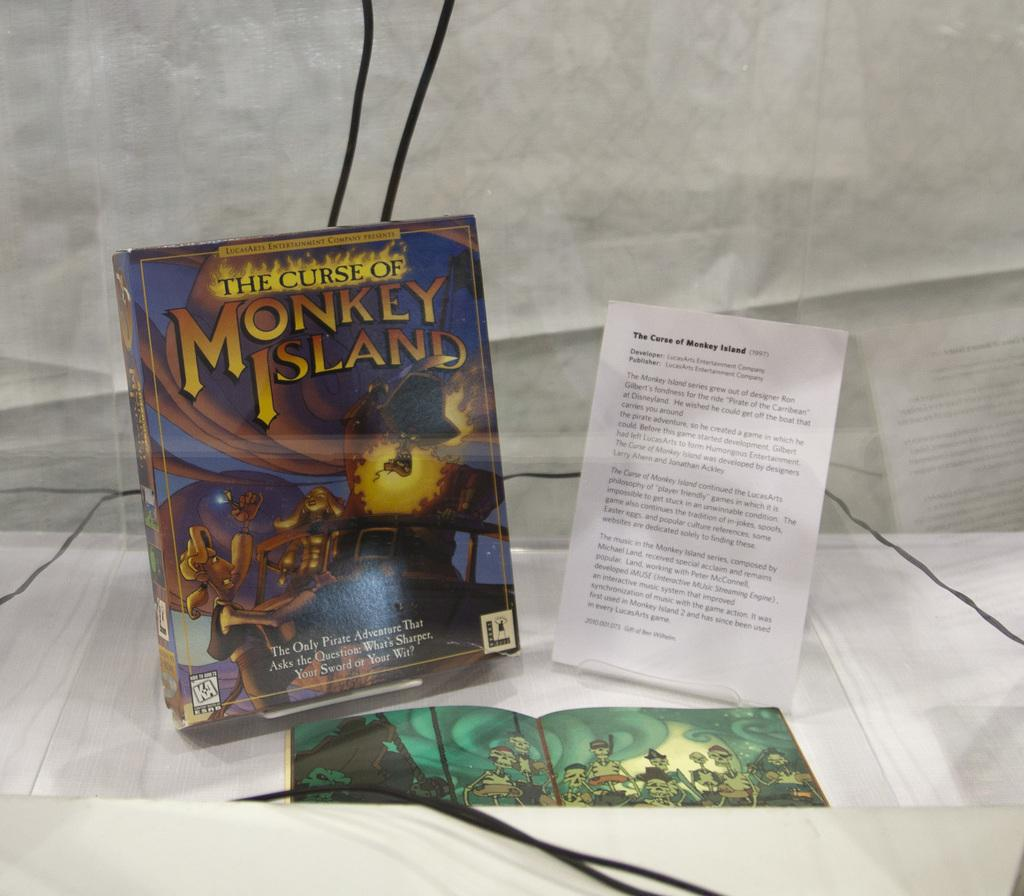<image>
Summarize the visual content of the image. A display box for the Curse of Monkey Island from Lucas Arts. 